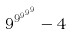<formula> <loc_0><loc_0><loc_500><loc_500>9 ^ { 9 ^ { 9 ^ { 9 ^ { 9 } } } } - 4</formula> 